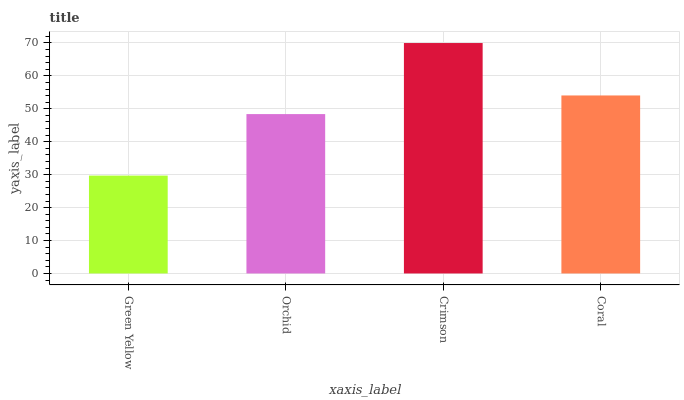Is Green Yellow the minimum?
Answer yes or no. Yes. Is Crimson the maximum?
Answer yes or no. Yes. Is Orchid the minimum?
Answer yes or no. No. Is Orchid the maximum?
Answer yes or no. No. Is Orchid greater than Green Yellow?
Answer yes or no. Yes. Is Green Yellow less than Orchid?
Answer yes or no. Yes. Is Green Yellow greater than Orchid?
Answer yes or no. No. Is Orchid less than Green Yellow?
Answer yes or no. No. Is Coral the high median?
Answer yes or no. Yes. Is Orchid the low median?
Answer yes or no. Yes. Is Crimson the high median?
Answer yes or no. No. Is Green Yellow the low median?
Answer yes or no. No. 